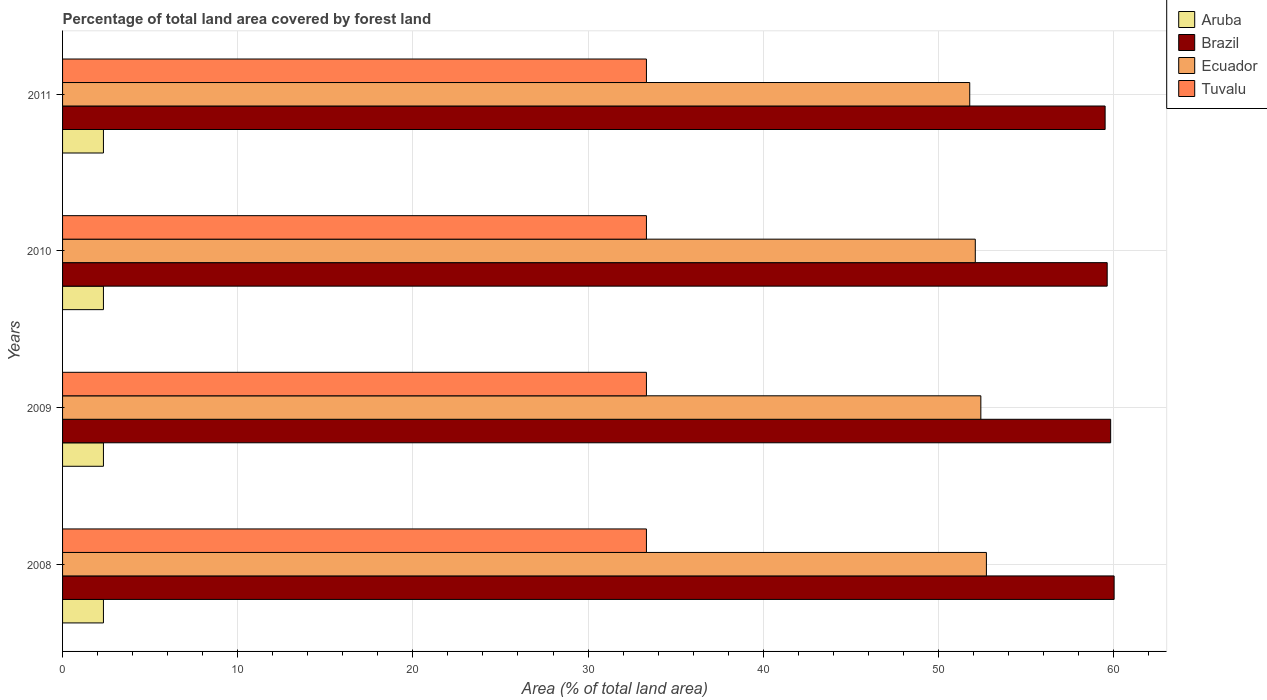How many different coloured bars are there?
Give a very brief answer. 4. Are the number of bars on each tick of the Y-axis equal?
Your answer should be very brief. Yes. How many bars are there on the 3rd tick from the top?
Provide a short and direct response. 4. How many bars are there on the 3rd tick from the bottom?
Provide a short and direct response. 4. What is the label of the 4th group of bars from the top?
Your answer should be compact. 2008. What is the percentage of forest land in Brazil in 2009?
Give a very brief answer. 59.84. Across all years, what is the maximum percentage of forest land in Ecuador?
Give a very brief answer. 52.74. Across all years, what is the minimum percentage of forest land in Brazil?
Provide a succinct answer. 59.52. In which year was the percentage of forest land in Ecuador maximum?
Offer a terse response. 2008. What is the total percentage of forest land in Brazil in the graph?
Ensure brevity in your answer.  239.03. What is the difference between the percentage of forest land in Aruba in 2009 and that in 2011?
Make the answer very short. 0. What is the difference between the percentage of forest land in Tuvalu in 2010 and the percentage of forest land in Aruba in 2011?
Provide a short and direct response. 31. What is the average percentage of forest land in Brazil per year?
Ensure brevity in your answer.  59.76. In the year 2008, what is the difference between the percentage of forest land in Tuvalu and percentage of forest land in Ecuador?
Provide a succinct answer. -19.41. What is the ratio of the percentage of forest land in Ecuador in 2008 to that in 2009?
Keep it short and to the point. 1.01. What is the difference between the highest and the lowest percentage of forest land in Tuvalu?
Your response must be concise. 0. In how many years, is the percentage of forest land in Tuvalu greater than the average percentage of forest land in Tuvalu taken over all years?
Your response must be concise. 0. What does the 2nd bar from the top in 2009 represents?
Your answer should be very brief. Ecuador. What does the 4th bar from the bottom in 2008 represents?
Provide a short and direct response. Tuvalu. Are all the bars in the graph horizontal?
Your response must be concise. Yes. What is the difference between two consecutive major ticks on the X-axis?
Your answer should be compact. 10. Are the values on the major ticks of X-axis written in scientific E-notation?
Offer a terse response. No. Does the graph contain any zero values?
Make the answer very short. No. Where does the legend appear in the graph?
Ensure brevity in your answer.  Top right. What is the title of the graph?
Offer a very short reply. Percentage of total land area covered by forest land. What is the label or title of the X-axis?
Provide a succinct answer. Area (% of total land area). What is the label or title of the Y-axis?
Ensure brevity in your answer.  Years. What is the Area (% of total land area) of Aruba in 2008?
Offer a very short reply. 2.33. What is the Area (% of total land area) of Brazil in 2008?
Your answer should be very brief. 60.03. What is the Area (% of total land area) in Ecuador in 2008?
Keep it short and to the point. 52.74. What is the Area (% of total land area) of Tuvalu in 2008?
Offer a very short reply. 33.33. What is the Area (% of total land area) of Aruba in 2009?
Offer a terse response. 2.33. What is the Area (% of total land area) of Brazil in 2009?
Your response must be concise. 59.84. What is the Area (% of total land area) in Ecuador in 2009?
Provide a succinct answer. 52.43. What is the Area (% of total land area) of Tuvalu in 2009?
Your response must be concise. 33.33. What is the Area (% of total land area) of Aruba in 2010?
Provide a succinct answer. 2.33. What is the Area (% of total land area) in Brazil in 2010?
Keep it short and to the point. 59.64. What is the Area (% of total land area) in Ecuador in 2010?
Give a very brief answer. 52.11. What is the Area (% of total land area) of Tuvalu in 2010?
Ensure brevity in your answer.  33.33. What is the Area (% of total land area) of Aruba in 2011?
Offer a very short reply. 2.33. What is the Area (% of total land area) in Brazil in 2011?
Offer a very short reply. 59.52. What is the Area (% of total land area) in Ecuador in 2011?
Your response must be concise. 51.79. What is the Area (% of total land area) in Tuvalu in 2011?
Offer a terse response. 33.33. Across all years, what is the maximum Area (% of total land area) of Aruba?
Ensure brevity in your answer.  2.33. Across all years, what is the maximum Area (% of total land area) in Brazil?
Provide a succinct answer. 60.03. Across all years, what is the maximum Area (% of total land area) of Ecuador?
Your response must be concise. 52.74. Across all years, what is the maximum Area (% of total land area) in Tuvalu?
Your answer should be compact. 33.33. Across all years, what is the minimum Area (% of total land area) in Aruba?
Provide a succinct answer. 2.33. Across all years, what is the minimum Area (% of total land area) of Brazil?
Provide a short and direct response. 59.52. Across all years, what is the minimum Area (% of total land area) of Ecuador?
Your response must be concise. 51.79. Across all years, what is the minimum Area (% of total land area) of Tuvalu?
Your answer should be compact. 33.33. What is the total Area (% of total land area) in Aruba in the graph?
Give a very brief answer. 9.33. What is the total Area (% of total land area) in Brazil in the graph?
Provide a succinct answer. 239.03. What is the total Area (% of total land area) in Ecuador in the graph?
Your response must be concise. 209.07. What is the total Area (% of total land area) in Tuvalu in the graph?
Your response must be concise. 133.33. What is the difference between the Area (% of total land area) of Aruba in 2008 and that in 2009?
Provide a short and direct response. 0. What is the difference between the Area (% of total land area) in Brazil in 2008 and that in 2009?
Your answer should be compact. 0.2. What is the difference between the Area (% of total land area) of Ecuador in 2008 and that in 2009?
Provide a succinct answer. 0.32. What is the difference between the Area (% of total land area) of Tuvalu in 2008 and that in 2009?
Your response must be concise. 0. What is the difference between the Area (% of total land area) of Aruba in 2008 and that in 2010?
Ensure brevity in your answer.  0. What is the difference between the Area (% of total land area) in Brazil in 2008 and that in 2010?
Offer a very short reply. 0.4. What is the difference between the Area (% of total land area) in Ecuador in 2008 and that in 2010?
Make the answer very short. 0.63. What is the difference between the Area (% of total land area) in Tuvalu in 2008 and that in 2010?
Provide a short and direct response. 0. What is the difference between the Area (% of total land area) of Aruba in 2008 and that in 2011?
Your answer should be very brief. 0. What is the difference between the Area (% of total land area) in Brazil in 2008 and that in 2011?
Offer a very short reply. 0.51. What is the difference between the Area (% of total land area) in Ecuador in 2008 and that in 2011?
Give a very brief answer. 0.95. What is the difference between the Area (% of total land area) in Tuvalu in 2008 and that in 2011?
Give a very brief answer. 0. What is the difference between the Area (% of total land area) of Aruba in 2009 and that in 2010?
Provide a short and direct response. 0. What is the difference between the Area (% of total land area) of Brazil in 2009 and that in 2010?
Your answer should be very brief. 0.2. What is the difference between the Area (% of total land area) of Ecuador in 2009 and that in 2010?
Make the answer very short. 0.32. What is the difference between the Area (% of total land area) in Tuvalu in 2009 and that in 2010?
Provide a short and direct response. 0. What is the difference between the Area (% of total land area) in Aruba in 2009 and that in 2011?
Your answer should be very brief. 0. What is the difference between the Area (% of total land area) of Brazil in 2009 and that in 2011?
Ensure brevity in your answer.  0.32. What is the difference between the Area (% of total land area) of Ecuador in 2009 and that in 2011?
Your answer should be very brief. 0.63. What is the difference between the Area (% of total land area) in Aruba in 2010 and that in 2011?
Your answer should be compact. 0. What is the difference between the Area (% of total land area) in Brazil in 2010 and that in 2011?
Your response must be concise. 0.12. What is the difference between the Area (% of total land area) in Ecuador in 2010 and that in 2011?
Your response must be concise. 0.32. What is the difference between the Area (% of total land area) of Tuvalu in 2010 and that in 2011?
Your response must be concise. 0. What is the difference between the Area (% of total land area) of Aruba in 2008 and the Area (% of total land area) of Brazil in 2009?
Provide a succinct answer. -57.5. What is the difference between the Area (% of total land area) in Aruba in 2008 and the Area (% of total land area) in Ecuador in 2009?
Make the answer very short. -50.09. What is the difference between the Area (% of total land area) of Aruba in 2008 and the Area (% of total land area) of Tuvalu in 2009?
Offer a very short reply. -31. What is the difference between the Area (% of total land area) of Brazil in 2008 and the Area (% of total land area) of Ecuador in 2009?
Keep it short and to the point. 7.61. What is the difference between the Area (% of total land area) of Brazil in 2008 and the Area (% of total land area) of Tuvalu in 2009?
Keep it short and to the point. 26.7. What is the difference between the Area (% of total land area) of Ecuador in 2008 and the Area (% of total land area) of Tuvalu in 2009?
Provide a short and direct response. 19.41. What is the difference between the Area (% of total land area) of Aruba in 2008 and the Area (% of total land area) of Brazil in 2010?
Keep it short and to the point. -57.3. What is the difference between the Area (% of total land area) in Aruba in 2008 and the Area (% of total land area) in Ecuador in 2010?
Your response must be concise. -49.77. What is the difference between the Area (% of total land area) of Aruba in 2008 and the Area (% of total land area) of Tuvalu in 2010?
Ensure brevity in your answer.  -31. What is the difference between the Area (% of total land area) in Brazil in 2008 and the Area (% of total land area) in Ecuador in 2010?
Give a very brief answer. 7.93. What is the difference between the Area (% of total land area) in Brazil in 2008 and the Area (% of total land area) in Tuvalu in 2010?
Offer a very short reply. 26.7. What is the difference between the Area (% of total land area) of Ecuador in 2008 and the Area (% of total land area) of Tuvalu in 2010?
Provide a succinct answer. 19.41. What is the difference between the Area (% of total land area) in Aruba in 2008 and the Area (% of total land area) in Brazil in 2011?
Provide a short and direct response. -57.19. What is the difference between the Area (% of total land area) in Aruba in 2008 and the Area (% of total land area) in Ecuador in 2011?
Offer a very short reply. -49.46. What is the difference between the Area (% of total land area) in Aruba in 2008 and the Area (% of total land area) in Tuvalu in 2011?
Provide a succinct answer. -31. What is the difference between the Area (% of total land area) of Brazil in 2008 and the Area (% of total land area) of Ecuador in 2011?
Provide a short and direct response. 8.24. What is the difference between the Area (% of total land area) in Brazil in 2008 and the Area (% of total land area) in Tuvalu in 2011?
Make the answer very short. 26.7. What is the difference between the Area (% of total land area) in Ecuador in 2008 and the Area (% of total land area) in Tuvalu in 2011?
Provide a short and direct response. 19.41. What is the difference between the Area (% of total land area) of Aruba in 2009 and the Area (% of total land area) of Brazil in 2010?
Provide a succinct answer. -57.3. What is the difference between the Area (% of total land area) in Aruba in 2009 and the Area (% of total land area) in Ecuador in 2010?
Give a very brief answer. -49.77. What is the difference between the Area (% of total land area) of Aruba in 2009 and the Area (% of total land area) of Tuvalu in 2010?
Your answer should be compact. -31. What is the difference between the Area (% of total land area) in Brazil in 2009 and the Area (% of total land area) in Ecuador in 2010?
Your answer should be very brief. 7.73. What is the difference between the Area (% of total land area) of Brazil in 2009 and the Area (% of total land area) of Tuvalu in 2010?
Provide a short and direct response. 26.5. What is the difference between the Area (% of total land area) of Ecuador in 2009 and the Area (% of total land area) of Tuvalu in 2010?
Keep it short and to the point. 19.09. What is the difference between the Area (% of total land area) in Aruba in 2009 and the Area (% of total land area) in Brazil in 2011?
Keep it short and to the point. -57.19. What is the difference between the Area (% of total land area) of Aruba in 2009 and the Area (% of total land area) of Ecuador in 2011?
Your response must be concise. -49.46. What is the difference between the Area (% of total land area) of Aruba in 2009 and the Area (% of total land area) of Tuvalu in 2011?
Offer a terse response. -31. What is the difference between the Area (% of total land area) in Brazil in 2009 and the Area (% of total land area) in Ecuador in 2011?
Ensure brevity in your answer.  8.04. What is the difference between the Area (% of total land area) of Brazil in 2009 and the Area (% of total land area) of Tuvalu in 2011?
Ensure brevity in your answer.  26.5. What is the difference between the Area (% of total land area) in Ecuador in 2009 and the Area (% of total land area) in Tuvalu in 2011?
Keep it short and to the point. 19.09. What is the difference between the Area (% of total land area) of Aruba in 2010 and the Area (% of total land area) of Brazil in 2011?
Ensure brevity in your answer.  -57.19. What is the difference between the Area (% of total land area) of Aruba in 2010 and the Area (% of total land area) of Ecuador in 2011?
Ensure brevity in your answer.  -49.46. What is the difference between the Area (% of total land area) in Aruba in 2010 and the Area (% of total land area) in Tuvalu in 2011?
Give a very brief answer. -31. What is the difference between the Area (% of total land area) in Brazil in 2010 and the Area (% of total land area) in Ecuador in 2011?
Offer a very short reply. 7.85. What is the difference between the Area (% of total land area) in Brazil in 2010 and the Area (% of total land area) in Tuvalu in 2011?
Give a very brief answer. 26.3. What is the difference between the Area (% of total land area) in Ecuador in 2010 and the Area (% of total land area) in Tuvalu in 2011?
Provide a succinct answer. 18.77. What is the average Area (% of total land area) of Aruba per year?
Provide a short and direct response. 2.33. What is the average Area (% of total land area) of Brazil per year?
Your response must be concise. 59.76. What is the average Area (% of total land area) in Ecuador per year?
Give a very brief answer. 52.27. What is the average Area (% of total land area) in Tuvalu per year?
Provide a succinct answer. 33.33. In the year 2008, what is the difference between the Area (% of total land area) in Aruba and Area (% of total land area) in Brazil?
Keep it short and to the point. -57.7. In the year 2008, what is the difference between the Area (% of total land area) of Aruba and Area (% of total land area) of Ecuador?
Your answer should be very brief. -50.41. In the year 2008, what is the difference between the Area (% of total land area) of Aruba and Area (% of total land area) of Tuvalu?
Make the answer very short. -31. In the year 2008, what is the difference between the Area (% of total land area) of Brazil and Area (% of total land area) of Ecuador?
Your answer should be very brief. 7.29. In the year 2008, what is the difference between the Area (% of total land area) in Brazil and Area (% of total land area) in Tuvalu?
Keep it short and to the point. 26.7. In the year 2008, what is the difference between the Area (% of total land area) of Ecuador and Area (% of total land area) of Tuvalu?
Your response must be concise. 19.41. In the year 2009, what is the difference between the Area (% of total land area) of Aruba and Area (% of total land area) of Brazil?
Offer a very short reply. -57.5. In the year 2009, what is the difference between the Area (% of total land area) in Aruba and Area (% of total land area) in Ecuador?
Ensure brevity in your answer.  -50.09. In the year 2009, what is the difference between the Area (% of total land area) in Aruba and Area (% of total land area) in Tuvalu?
Give a very brief answer. -31. In the year 2009, what is the difference between the Area (% of total land area) in Brazil and Area (% of total land area) in Ecuador?
Your answer should be compact. 7.41. In the year 2009, what is the difference between the Area (% of total land area) of Brazil and Area (% of total land area) of Tuvalu?
Ensure brevity in your answer.  26.5. In the year 2009, what is the difference between the Area (% of total land area) in Ecuador and Area (% of total land area) in Tuvalu?
Your response must be concise. 19.09. In the year 2010, what is the difference between the Area (% of total land area) of Aruba and Area (% of total land area) of Brazil?
Provide a short and direct response. -57.3. In the year 2010, what is the difference between the Area (% of total land area) in Aruba and Area (% of total land area) in Ecuador?
Offer a terse response. -49.77. In the year 2010, what is the difference between the Area (% of total land area) in Aruba and Area (% of total land area) in Tuvalu?
Provide a short and direct response. -31. In the year 2010, what is the difference between the Area (% of total land area) in Brazil and Area (% of total land area) in Ecuador?
Your answer should be very brief. 7.53. In the year 2010, what is the difference between the Area (% of total land area) of Brazil and Area (% of total land area) of Tuvalu?
Make the answer very short. 26.3. In the year 2010, what is the difference between the Area (% of total land area) of Ecuador and Area (% of total land area) of Tuvalu?
Make the answer very short. 18.77. In the year 2011, what is the difference between the Area (% of total land area) in Aruba and Area (% of total land area) in Brazil?
Make the answer very short. -57.19. In the year 2011, what is the difference between the Area (% of total land area) of Aruba and Area (% of total land area) of Ecuador?
Keep it short and to the point. -49.46. In the year 2011, what is the difference between the Area (% of total land area) in Aruba and Area (% of total land area) in Tuvalu?
Your response must be concise. -31. In the year 2011, what is the difference between the Area (% of total land area) of Brazil and Area (% of total land area) of Ecuador?
Keep it short and to the point. 7.73. In the year 2011, what is the difference between the Area (% of total land area) in Brazil and Area (% of total land area) in Tuvalu?
Provide a succinct answer. 26.19. In the year 2011, what is the difference between the Area (% of total land area) in Ecuador and Area (% of total land area) in Tuvalu?
Ensure brevity in your answer.  18.46. What is the ratio of the Area (% of total land area) of Ecuador in 2008 to that in 2009?
Provide a short and direct response. 1.01. What is the ratio of the Area (% of total land area) in Brazil in 2008 to that in 2010?
Your answer should be very brief. 1.01. What is the ratio of the Area (% of total land area) of Ecuador in 2008 to that in 2010?
Your answer should be very brief. 1.01. What is the ratio of the Area (% of total land area) of Aruba in 2008 to that in 2011?
Keep it short and to the point. 1. What is the ratio of the Area (% of total land area) of Brazil in 2008 to that in 2011?
Provide a succinct answer. 1.01. What is the ratio of the Area (% of total land area) in Ecuador in 2008 to that in 2011?
Make the answer very short. 1.02. What is the ratio of the Area (% of total land area) in Aruba in 2009 to that in 2010?
Provide a succinct answer. 1. What is the ratio of the Area (% of total land area) of Brazil in 2009 to that in 2010?
Provide a short and direct response. 1. What is the ratio of the Area (% of total land area) of Aruba in 2009 to that in 2011?
Offer a terse response. 1. What is the ratio of the Area (% of total land area) in Brazil in 2009 to that in 2011?
Provide a succinct answer. 1.01. What is the ratio of the Area (% of total land area) in Ecuador in 2009 to that in 2011?
Ensure brevity in your answer.  1.01. What is the ratio of the Area (% of total land area) in Tuvalu in 2009 to that in 2011?
Make the answer very short. 1. What is the ratio of the Area (% of total land area) of Aruba in 2010 to that in 2011?
Offer a terse response. 1. What is the difference between the highest and the second highest Area (% of total land area) in Brazil?
Keep it short and to the point. 0.2. What is the difference between the highest and the second highest Area (% of total land area) of Ecuador?
Give a very brief answer. 0.32. What is the difference between the highest and the second highest Area (% of total land area) in Tuvalu?
Offer a very short reply. 0. What is the difference between the highest and the lowest Area (% of total land area) of Aruba?
Your answer should be compact. 0. What is the difference between the highest and the lowest Area (% of total land area) of Brazil?
Offer a very short reply. 0.51. What is the difference between the highest and the lowest Area (% of total land area) of Ecuador?
Provide a short and direct response. 0.95. 